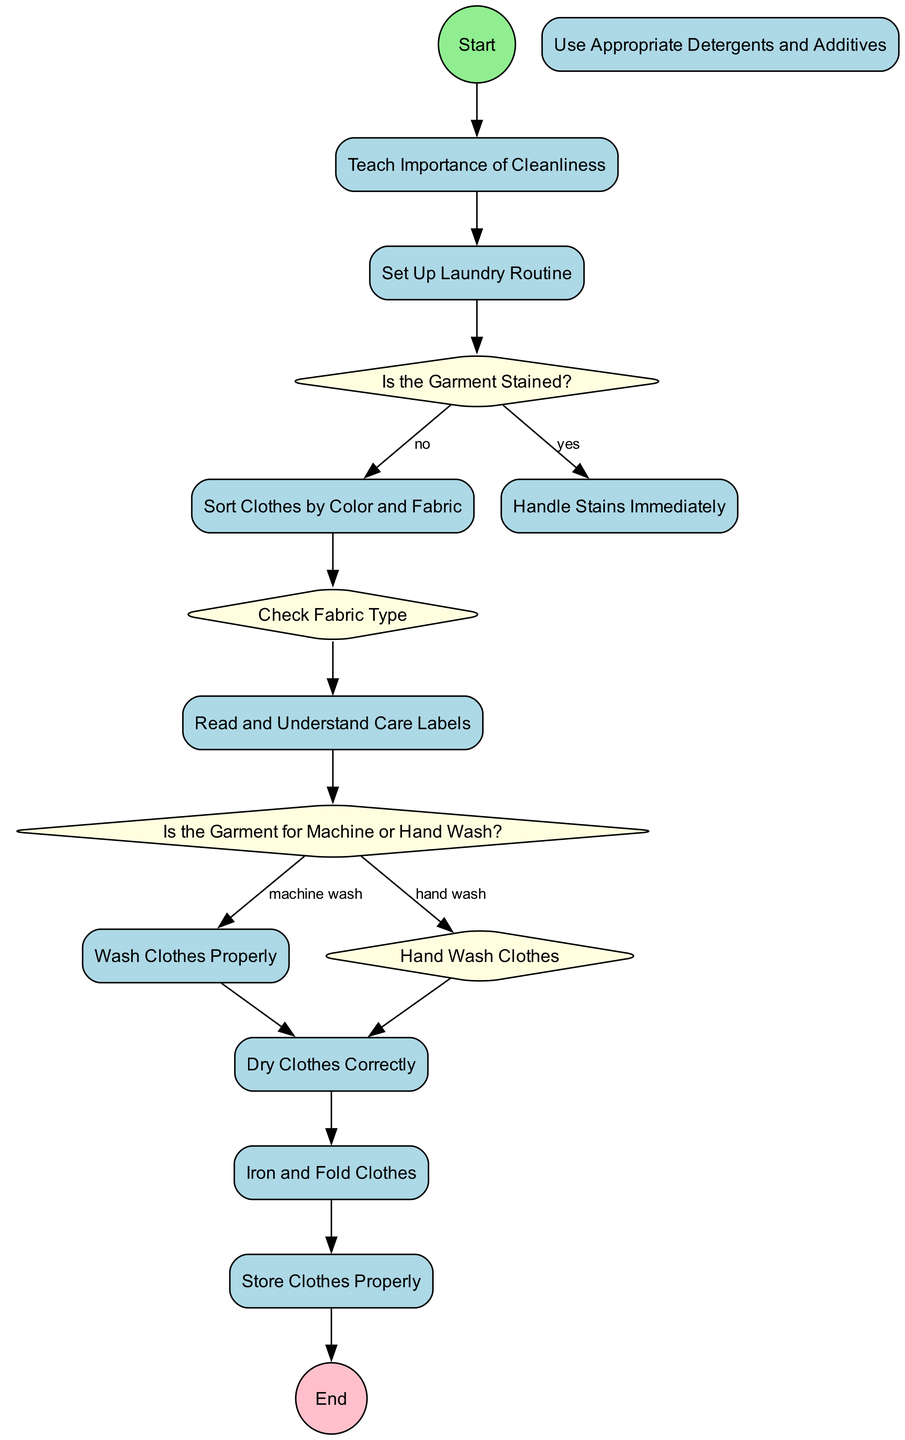What is the first activity in the diagram? The diagram starts with the "Start" node, which then flows into the "Teach Importance of Cleanliness" activity. Therefore, the first activity is the one that follows the start node.
Answer: Teach Importance of Cleanliness How many decision nodes are present in the diagram? There are three decision nodes: "Is the Garment Stained?", "Is the Garment for Machine or Hand Wash?", and "Check Fabric Type". Counting these gives a total of three decision nodes.
Answer: 3 What activity follows "Set Up Laundry Routine"? The flow from "Set Up Laundry Routine" leads directly to the decision node "Is the Garment Stained?". Thus, it is the next activity that occurs in the sequence.
Answer: Is the Garment Stained? What is the last activity before reaching the end of the diagram? The last activity that occurs before reaching the "End" node is "Store Clothes Properly", which is the final step in the flow of the diagram.
Answer: Store Clothes Properly If a garment has stains, what is the next step? If a garment is found to be stained, the diagram indicates that the next activity is to "Handle Stains Immediately". This is directly connected to the decision node about stains.
Answer: Handle Stains Immediately What must be checked after sorting clothes? After sorting clothes by color and fabric, the next step is to "Check Fabric Type". This follows sequentially from the sorting activity according to the diagram's flow.
Answer: Check Fabric Type How many activities are there in total in the diagram? Counting each activity listed in the diagram, we find there are ten distinct activities: from "Teach Importance of Cleanliness" to "Store Clothes Properly". Thus, the total number of activities is ten.
Answer: 10 Which activity teaches about proper drying methods? The activity that teaches about various drying methods is "Dry Clothes Correctly". This activity focuses on the different ways to properly dry clothes depending on the fabric type.
Answer: Dry Clothes Correctly What is required to determine washing methods for a garment? To decide on the proper washing method for a garment, one must check the care label instructions, which is reflected in the decision node "Is the Garment for Machine or Hand Wash?".
Answer: Read and Understand Care Labels 